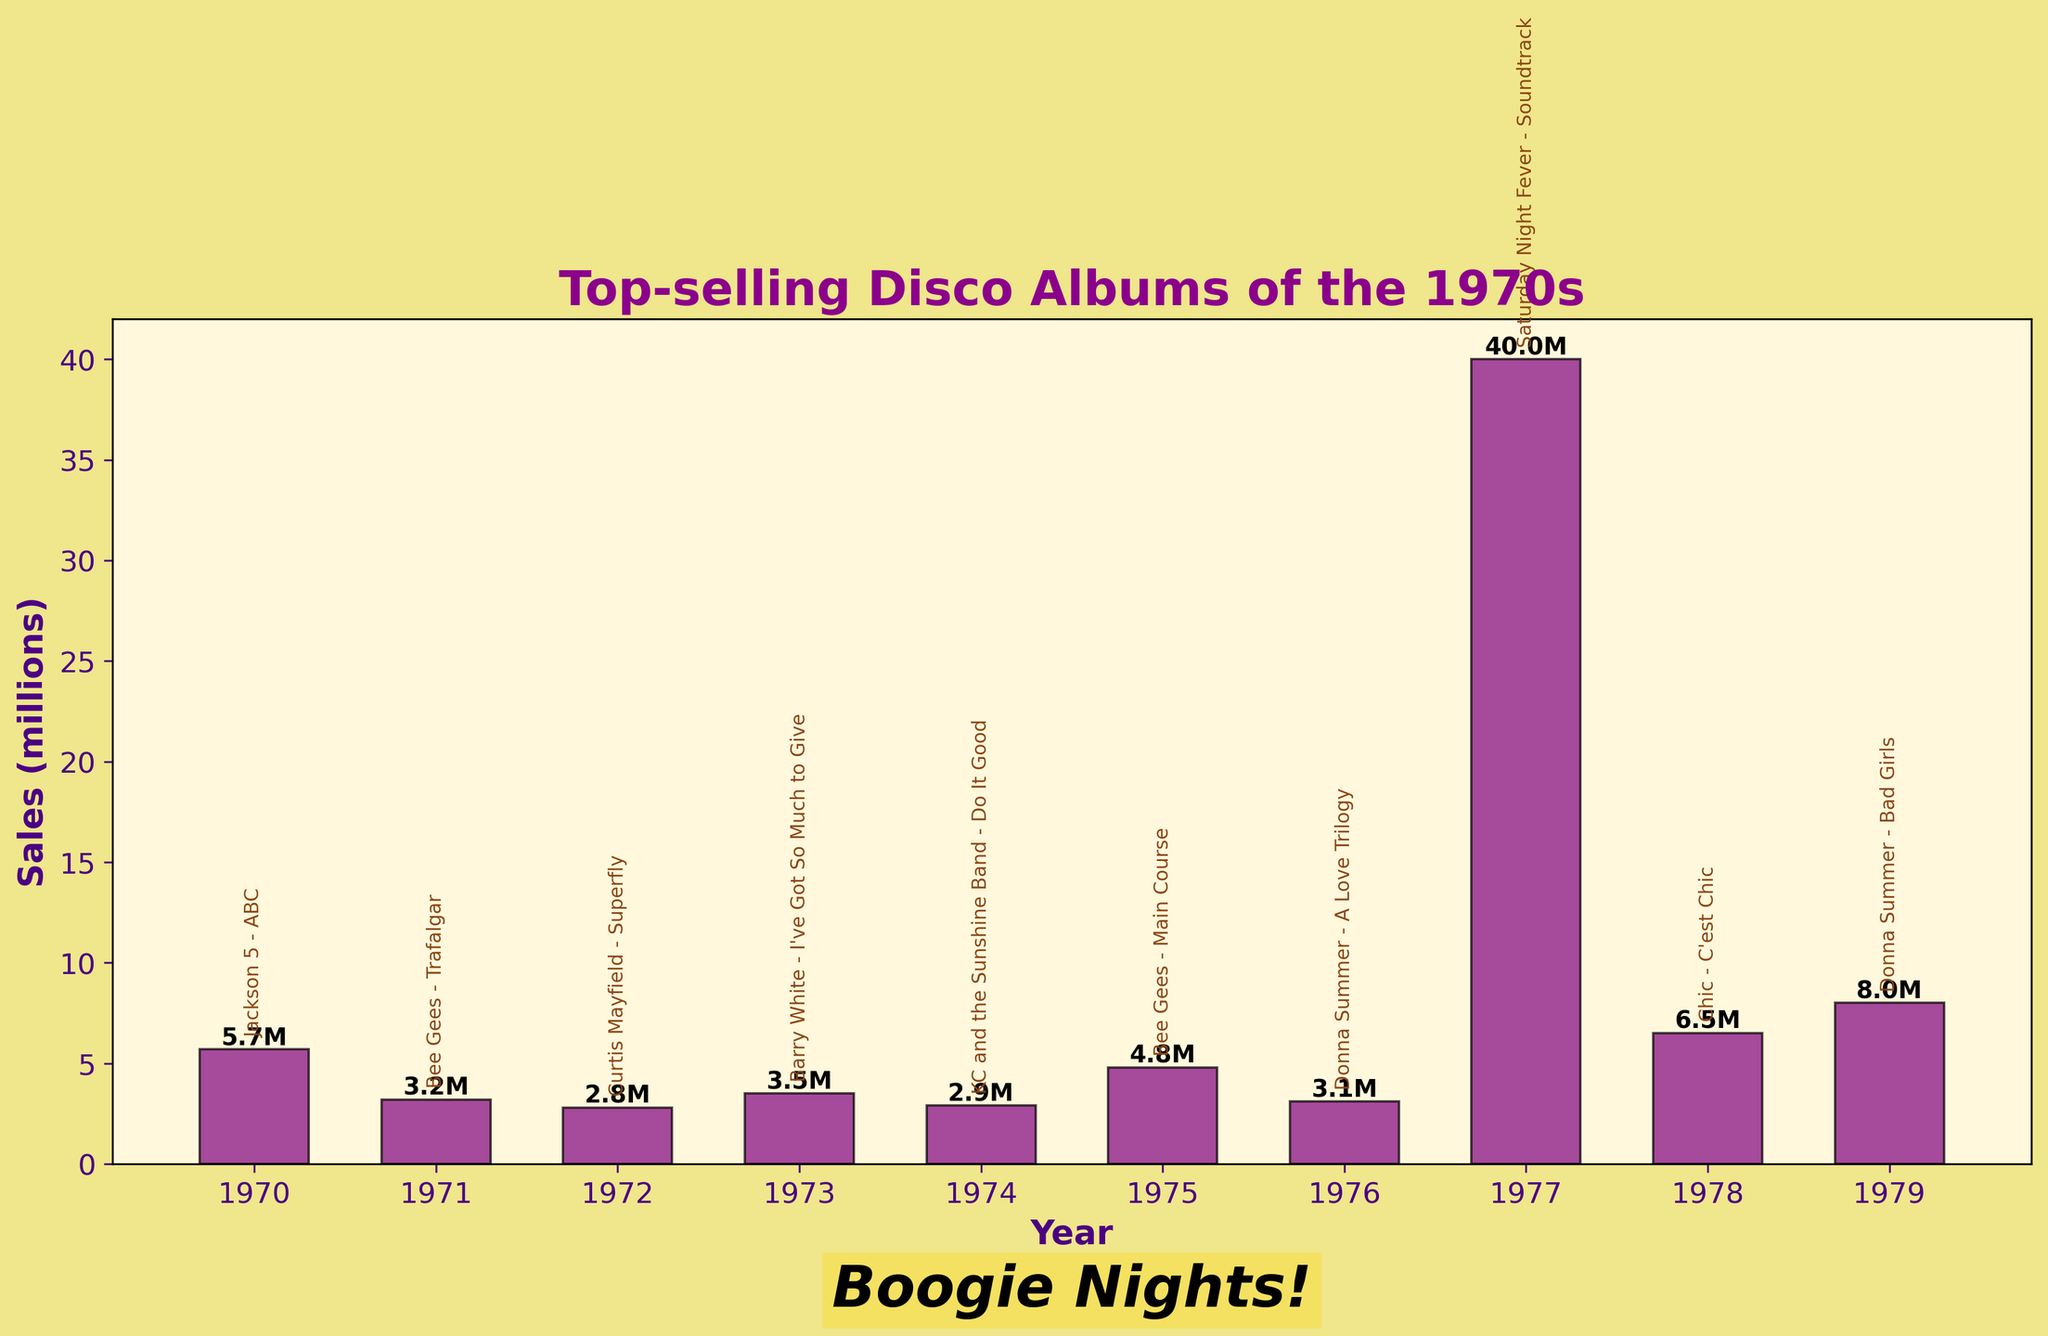Which album sold the most in the 1970s? To identify the album with the highest sales, look for the tallest bar in the chart, which represents 1977 with the "Saturday Night Fever - Soundtrack" album.
Answer: Saturday Night Fever - Soundtrack What is the difference in sales between the top-selling album "Saturday Night Fever - Soundtrack" and the second top-selling album "Donna Summer - Bad Girls"? The sales of the top-selling album are 40.0 million, and the sales of the second top-selling album are 8.0 million. The difference is 40.0 - 8.0 = 32.0 million.
Answer: 32.0 million Which artist has the most albums listed in the top-selling disco albums of the 1970s? To determine which artist has the most albums listed, count the number of times each artist appears in the dataset. The Bee Gees and Donna Summer each appear twice.
Answer: Bee Gees, Donna Summer How much did the sales of the "Jackson 5 - ABC" album exceed the sales of the "Curtis Mayfield - Superfly" album? The sales of the "Jackson 5 - ABC" album are 5.7 million, and the sales of the "Curtis Mayfield - Superfly" album are 2.8 million. The difference is 5.7 - 2.8 = 2.9 million.
Answer: 2.9 million What is the average sales of the albums listed in the chart? To find the average sales, sum the sales values of all albums and divide by the number of albums. The total sales are 5.7 + 3.2 + 2.8 + 3.5 + 2.9 + 4.8 + 3.1 + 40.0 + 6.5 + 8.0 = 80.5 million. The number of albums is 10. The average sales are 80.5 / 10 = 8.05 million.
Answer: 8.05 million In which year does the chart show the lowest album sales? Look for the shortest bar in the chart, which represents 1972 with the album "Curtis Mayfield - Superfly" at 2.8 million.
Answer: 1972 Which album released in 1973 outperformed the album released in 1971 in terms of sales? Compare the sales of the albums released in 1973 ("Barry White - I've Got So Much to Give" with 3.5 million) and 1971 ("Bee Gees - Trafalgar" with 3.2 million). 3.5 > 3.2, so the album from 1973 outperformed.
Answer: Barry White - I've Got So Much to Give What is the total sales of all albums released in 1975 and 1979 combined? Sum the sales of the albums from 1975 ("Bee Gees - Main Course" with 4.8 million) and 1979 ("Donna Summer - Bad Girls" with 8.0 million). The total is 4.8 + 8.0 = 12.8 million.
Answer: 12.8 million Which year had both the highest and the lowest sales among the top-selling disco albums of the 1970s? First, determine the year with the highest sales (1977 with 40.0 million) and compare it to the year with the lowest sales (1972 with 2.8 million). Only 1977 had the highest sales while 1972 had the lowest. Therefore, no single year had both the highest and lowest sales.
Answer: None 